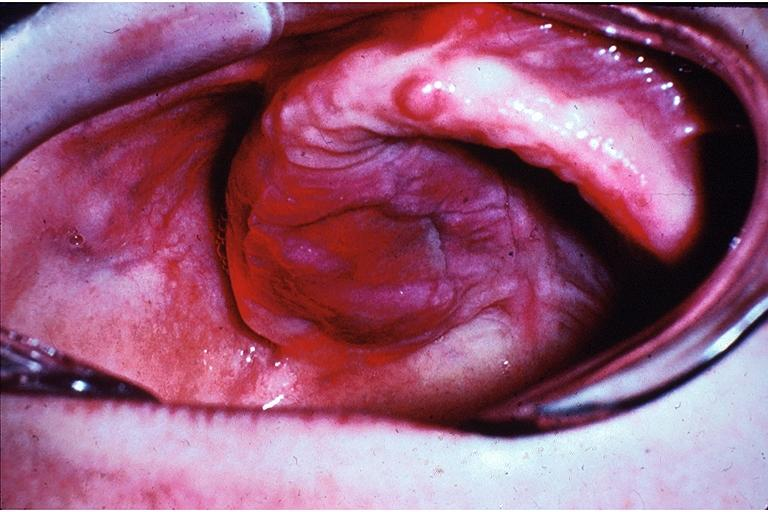what does this image show?
Answer the question using a single word or phrase. Lymphoproliferative disease of the palate 